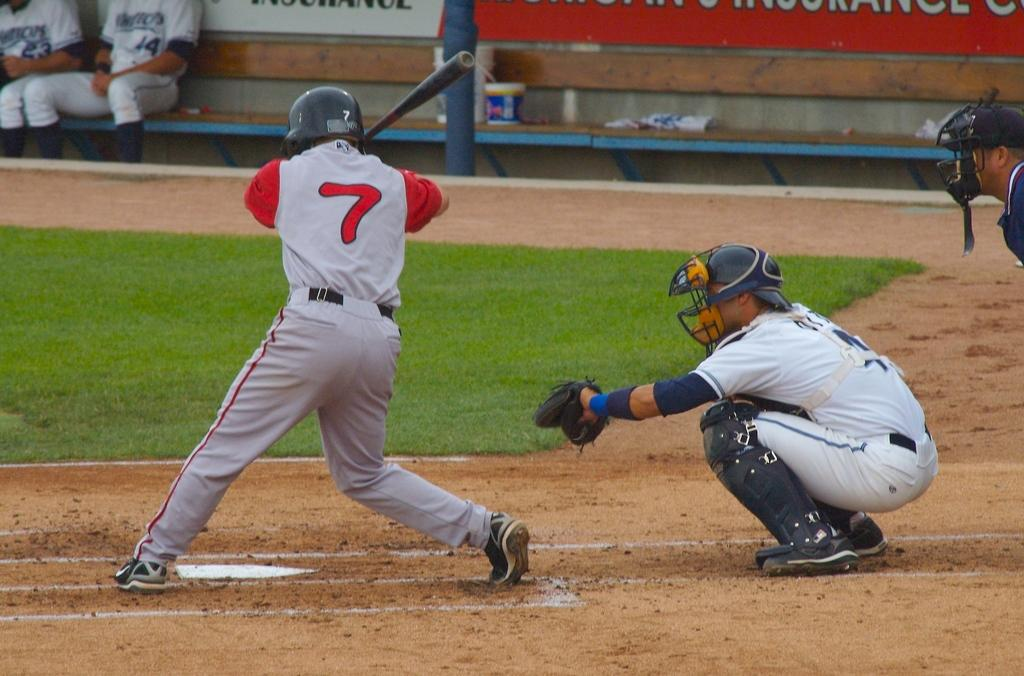<image>
Describe the image concisely. A baseball player with a gray and red uniform with the number seven on his back is about to swing his bat. 